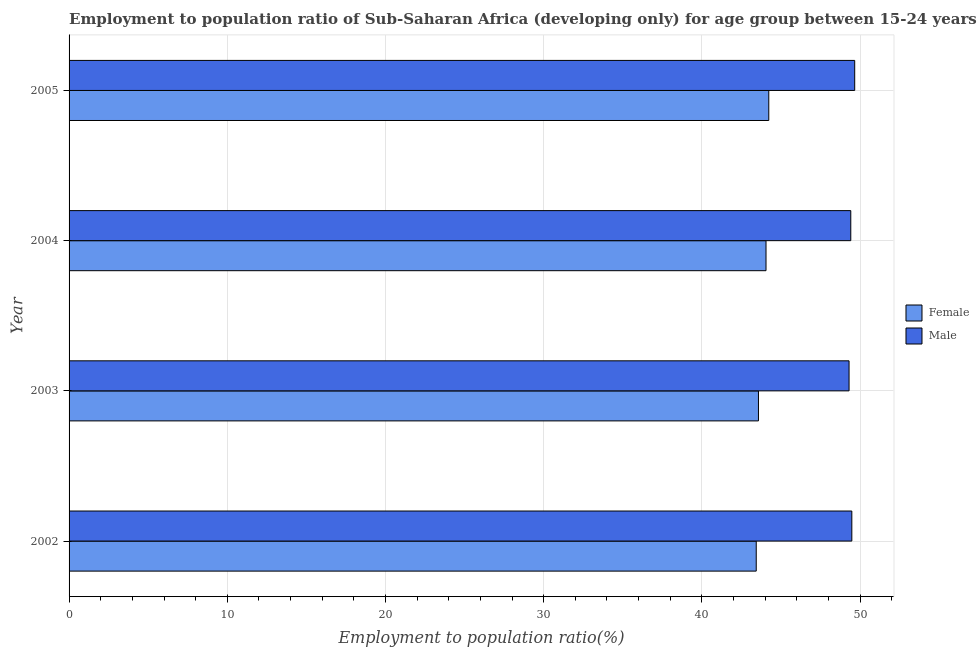Are the number of bars on each tick of the Y-axis equal?
Provide a succinct answer. Yes. How many bars are there on the 1st tick from the bottom?
Make the answer very short. 2. What is the label of the 2nd group of bars from the top?
Ensure brevity in your answer.  2004. In how many cases, is the number of bars for a given year not equal to the number of legend labels?
Provide a short and direct response. 0. What is the employment to population ratio(female) in 2005?
Give a very brief answer. 44.23. Across all years, what is the maximum employment to population ratio(male)?
Your answer should be very brief. 49.66. Across all years, what is the minimum employment to population ratio(male)?
Make the answer very short. 49.3. In which year was the employment to population ratio(male) maximum?
Your answer should be very brief. 2005. What is the total employment to population ratio(male) in the graph?
Your response must be concise. 197.85. What is the difference between the employment to population ratio(male) in 2003 and that in 2004?
Your answer should be very brief. -0.11. What is the difference between the employment to population ratio(female) in 2002 and the employment to population ratio(male) in 2003?
Keep it short and to the point. -5.87. What is the average employment to population ratio(female) per year?
Your answer should be compact. 43.82. In the year 2002, what is the difference between the employment to population ratio(female) and employment to population ratio(male)?
Provide a succinct answer. -6.04. In how many years, is the employment to population ratio(male) greater than 46 %?
Provide a short and direct response. 4. What is the ratio of the employment to population ratio(male) in 2002 to that in 2003?
Offer a terse response. 1. What is the difference between the highest and the second highest employment to population ratio(male)?
Your answer should be very brief. 0.18. What is the difference between the highest and the lowest employment to population ratio(female)?
Offer a very short reply. 0.79. Are all the bars in the graph horizontal?
Offer a terse response. Yes. What is the difference between two consecutive major ticks on the X-axis?
Your answer should be compact. 10. Does the graph contain any zero values?
Your answer should be very brief. No. Where does the legend appear in the graph?
Make the answer very short. Center right. How many legend labels are there?
Your answer should be compact. 2. How are the legend labels stacked?
Ensure brevity in your answer.  Vertical. What is the title of the graph?
Ensure brevity in your answer.  Employment to population ratio of Sub-Saharan Africa (developing only) for age group between 15-24 years. What is the label or title of the Y-axis?
Give a very brief answer. Year. What is the Employment to population ratio(%) of Female in 2002?
Give a very brief answer. 43.43. What is the Employment to population ratio(%) in Male in 2002?
Offer a very short reply. 49.48. What is the Employment to population ratio(%) in Female in 2003?
Provide a short and direct response. 43.58. What is the Employment to population ratio(%) in Male in 2003?
Your response must be concise. 49.3. What is the Employment to population ratio(%) of Female in 2004?
Provide a succinct answer. 44.05. What is the Employment to population ratio(%) of Male in 2004?
Your answer should be very brief. 49.41. What is the Employment to population ratio(%) of Female in 2005?
Your answer should be very brief. 44.23. What is the Employment to population ratio(%) in Male in 2005?
Make the answer very short. 49.66. Across all years, what is the maximum Employment to population ratio(%) of Female?
Give a very brief answer. 44.23. Across all years, what is the maximum Employment to population ratio(%) in Male?
Provide a short and direct response. 49.66. Across all years, what is the minimum Employment to population ratio(%) of Female?
Offer a terse response. 43.43. Across all years, what is the minimum Employment to population ratio(%) of Male?
Offer a terse response. 49.3. What is the total Employment to population ratio(%) in Female in the graph?
Offer a terse response. 175.29. What is the total Employment to population ratio(%) of Male in the graph?
Give a very brief answer. 197.85. What is the difference between the Employment to population ratio(%) in Female in 2002 and that in 2003?
Provide a short and direct response. -0.14. What is the difference between the Employment to population ratio(%) of Male in 2002 and that in 2003?
Offer a terse response. 0.18. What is the difference between the Employment to population ratio(%) in Female in 2002 and that in 2004?
Offer a terse response. -0.62. What is the difference between the Employment to population ratio(%) of Male in 2002 and that in 2004?
Give a very brief answer. 0.07. What is the difference between the Employment to population ratio(%) in Female in 2002 and that in 2005?
Make the answer very short. -0.79. What is the difference between the Employment to population ratio(%) in Male in 2002 and that in 2005?
Provide a short and direct response. -0.18. What is the difference between the Employment to population ratio(%) of Female in 2003 and that in 2004?
Offer a terse response. -0.48. What is the difference between the Employment to population ratio(%) in Male in 2003 and that in 2004?
Provide a succinct answer. -0.11. What is the difference between the Employment to population ratio(%) in Female in 2003 and that in 2005?
Provide a short and direct response. -0.65. What is the difference between the Employment to population ratio(%) in Male in 2003 and that in 2005?
Provide a succinct answer. -0.36. What is the difference between the Employment to population ratio(%) in Female in 2004 and that in 2005?
Provide a succinct answer. -0.17. What is the difference between the Employment to population ratio(%) in Male in 2004 and that in 2005?
Your answer should be compact. -0.25. What is the difference between the Employment to population ratio(%) of Female in 2002 and the Employment to population ratio(%) of Male in 2003?
Ensure brevity in your answer.  -5.87. What is the difference between the Employment to population ratio(%) of Female in 2002 and the Employment to population ratio(%) of Male in 2004?
Offer a terse response. -5.98. What is the difference between the Employment to population ratio(%) in Female in 2002 and the Employment to population ratio(%) in Male in 2005?
Give a very brief answer. -6.22. What is the difference between the Employment to population ratio(%) of Female in 2003 and the Employment to population ratio(%) of Male in 2004?
Provide a succinct answer. -5.84. What is the difference between the Employment to population ratio(%) in Female in 2003 and the Employment to population ratio(%) in Male in 2005?
Offer a very short reply. -6.08. What is the difference between the Employment to population ratio(%) of Female in 2004 and the Employment to population ratio(%) of Male in 2005?
Keep it short and to the point. -5.61. What is the average Employment to population ratio(%) in Female per year?
Give a very brief answer. 43.82. What is the average Employment to population ratio(%) in Male per year?
Keep it short and to the point. 49.46. In the year 2002, what is the difference between the Employment to population ratio(%) of Female and Employment to population ratio(%) of Male?
Provide a succinct answer. -6.04. In the year 2003, what is the difference between the Employment to population ratio(%) of Female and Employment to population ratio(%) of Male?
Give a very brief answer. -5.73. In the year 2004, what is the difference between the Employment to population ratio(%) in Female and Employment to population ratio(%) in Male?
Offer a terse response. -5.36. In the year 2005, what is the difference between the Employment to population ratio(%) in Female and Employment to population ratio(%) in Male?
Ensure brevity in your answer.  -5.43. What is the ratio of the Employment to population ratio(%) of Female in 2002 to that in 2003?
Your answer should be compact. 1. What is the ratio of the Employment to population ratio(%) of Male in 2002 to that in 2003?
Offer a very short reply. 1. What is the ratio of the Employment to population ratio(%) in Female in 2002 to that in 2004?
Offer a very short reply. 0.99. What is the ratio of the Employment to population ratio(%) in Male in 2002 to that in 2004?
Provide a short and direct response. 1. What is the ratio of the Employment to population ratio(%) of Female in 2002 to that in 2005?
Offer a terse response. 0.98. What is the ratio of the Employment to population ratio(%) in Female in 2003 to that in 2005?
Your answer should be very brief. 0.99. What is the ratio of the Employment to population ratio(%) of Female in 2004 to that in 2005?
Keep it short and to the point. 1. What is the ratio of the Employment to population ratio(%) of Male in 2004 to that in 2005?
Offer a terse response. 0.99. What is the difference between the highest and the second highest Employment to population ratio(%) in Female?
Your response must be concise. 0.17. What is the difference between the highest and the second highest Employment to population ratio(%) in Male?
Your answer should be very brief. 0.18. What is the difference between the highest and the lowest Employment to population ratio(%) of Female?
Offer a very short reply. 0.79. What is the difference between the highest and the lowest Employment to population ratio(%) in Male?
Your response must be concise. 0.36. 